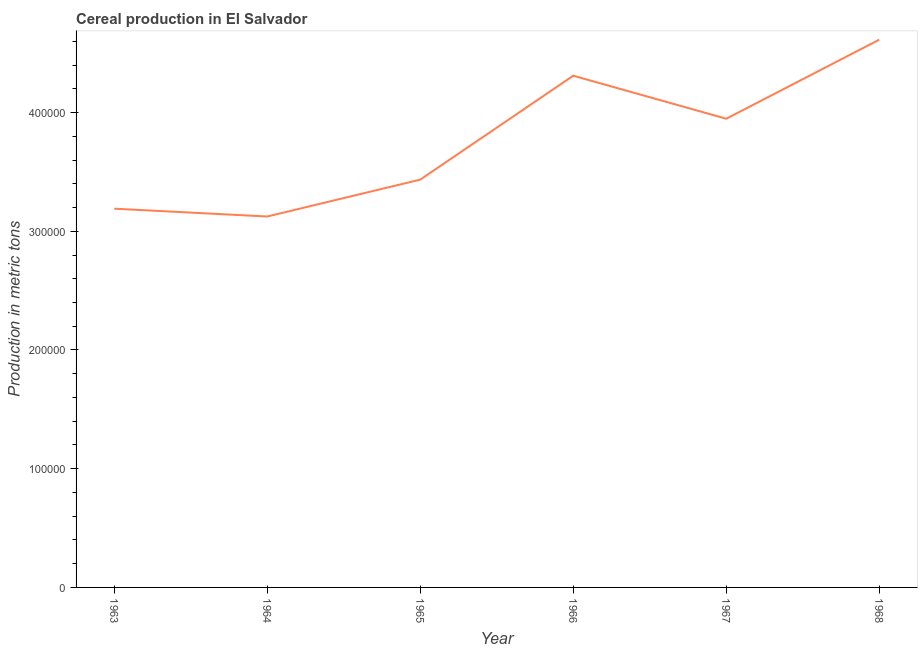What is the cereal production in 1963?
Provide a succinct answer. 3.19e+05. Across all years, what is the maximum cereal production?
Offer a terse response. 4.61e+05. Across all years, what is the minimum cereal production?
Provide a short and direct response. 3.12e+05. In which year was the cereal production maximum?
Provide a succinct answer. 1968. In which year was the cereal production minimum?
Offer a terse response. 1964. What is the sum of the cereal production?
Provide a succinct answer. 2.26e+06. What is the difference between the cereal production in 1963 and 1965?
Your response must be concise. -2.45e+04. What is the average cereal production per year?
Your answer should be compact. 3.77e+05. What is the median cereal production?
Give a very brief answer. 3.69e+05. In how many years, is the cereal production greater than 380000 metric tons?
Make the answer very short. 3. What is the ratio of the cereal production in 1965 to that in 1968?
Provide a short and direct response. 0.74. Is the cereal production in 1965 less than that in 1968?
Provide a succinct answer. Yes. Is the difference between the cereal production in 1967 and 1968 greater than the difference between any two years?
Provide a succinct answer. No. What is the difference between the highest and the second highest cereal production?
Offer a very short reply. 3.04e+04. What is the difference between the highest and the lowest cereal production?
Keep it short and to the point. 1.49e+05. How many lines are there?
Offer a very short reply. 1. How many years are there in the graph?
Make the answer very short. 6. What is the difference between two consecutive major ticks on the Y-axis?
Your answer should be very brief. 1.00e+05. Does the graph contain any zero values?
Offer a terse response. No. Does the graph contain grids?
Your answer should be very brief. No. What is the title of the graph?
Offer a very short reply. Cereal production in El Salvador. What is the label or title of the Y-axis?
Give a very brief answer. Production in metric tons. What is the Production in metric tons of 1963?
Keep it short and to the point. 3.19e+05. What is the Production in metric tons in 1964?
Your answer should be compact. 3.12e+05. What is the Production in metric tons of 1965?
Offer a very short reply. 3.43e+05. What is the Production in metric tons in 1966?
Provide a succinct answer. 4.31e+05. What is the Production in metric tons of 1967?
Make the answer very short. 3.95e+05. What is the Production in metric tons of 1968?
Provide a short and direct response. 4.61e+05. What is the difference between the Production in metric tons in 1963 and 1964?
Give a very brief answer. 6583. What is the difference between the Production in metric tons in 1963 and 1965?
Your answer should be very brief. -2.45e+04. What is the difference between the Production in metric tons in 1963 and 1966?
Provide a succinct answer. -1.12e+05. What is the difference between the Production in metric tons in 1963 and 1967?
Give a very brief answer. -7.58e+04. What is the difference between the Production in metric tons in 1963 and 1968?
Your answer should be compact. -1.42e+05. What is the difference between the Production in metric tons in 1964 and 1965?
Provide a short and direct response. -3.11e+04. What is the difference between the Production in metric tons in 1964 and 1966?
Your response must be concise. -1.19e+05. What is the difference between the Production in metric tons in 1964 and 1967?
Provide a short and direct response. -8.24e+04. What is the difference between the Production in metric tons in 1964 and 1968?
Keep it short and to the point. -1.49e+05. What is the difference between the Production in metric tons in 1965 and 1966?
Ensure brevity in your answer.  -8.75e+04. What is the difference between the Production in metric tons in 1965 and 1967?
Ensure brevity in your answer.  -5.13e+04. What is the difference between the Production in metric tons in 1965 and 1968?
Ensure brevity in your answer.  -1.18e+05. What is the difference between the Production in metric tons in 1966 and 1967?
Provide a succinct answer. 3.62e+04. What is the difference between the Production in metric tons in 1966 and 1968?
Provide a succinct answer. -3.04e+04. What is the difference between the Production in metric tons in 1967 and 1968?
Your answer should be compact. -6.66e+04. What is the ratio of the Production in metric tons in 1963 to that in 1965?
Your answer should be compact. 0.93. What is the ratio of the Production in metric tons in 1963 to that in 1966?
Provide a succinct answer. 0.74. What is the ratio of the Production in metric tons in 1963 to that in 1967?
Offer a very short reply. 0.81. What is the ratio of the Production in metric tons in 1963 to that in 1968?
Your response must be concise. 0.69. What is the ratio of the Production in metric tons in 1964 to that in 1965?
Provide a succinct answer. 0.91. What is the ratio of the Production in metric tons in 1964 to that in 1966?
Ensure brevity in your answer.  0.72. What is the ratio of the Production in metric tons in 1964 to that in 1967?
Ensure brevity in your answer.  0.79. What is the ratio of the Production in metric tons in 1964 to that in 1968?
Offer a very short reply. 0.68. What is the ratio of the Production in metric tons in 1965 to that in 1966?
Ensure brevity in your answer.  0.8. What is the ratio of the Production in metric tons in 1965 to that in 1967?
Keep it short and to the point. 0.87. What is the ratio of the Production in metric tons in 1965 to that in 1968?
Offer a very short reply. 0.74. What is the ratio of the Production in metric tons in 1966 to that in 1967?
Make the answer very short. 1.09. What is the ratio of the Production in metric tons in 1966 to that in 1968?
Your answer should be compact. 0.93. What is the ratio of the Production in metric tons in 1967 to that in 1968?
Keep it short and to the point. 0.86. 